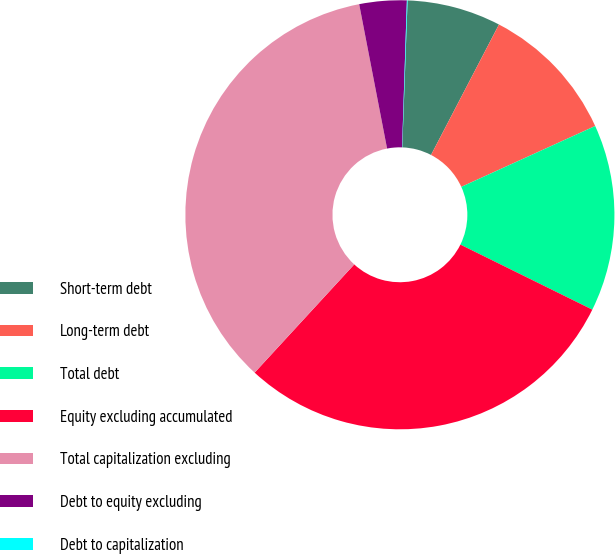Convert chart. <chart><loc_0><loc_0><loc_500><loc_500><pie_chart><fcel>Short-term debt<fcel>Long-term debt<fcel>Total debt<fcel>Equity excluding accumulated<fcel>Total capitalization excluding<fcel>Debt to equity excluding<fcel>Debt to capitalization<nl><fcel>7.07%<fcel>10.57%<fcel>14.08%<fcel>29.55%<fcel>35.12%<fcel>3.56%<fcel>0.05%<nl></chart> 